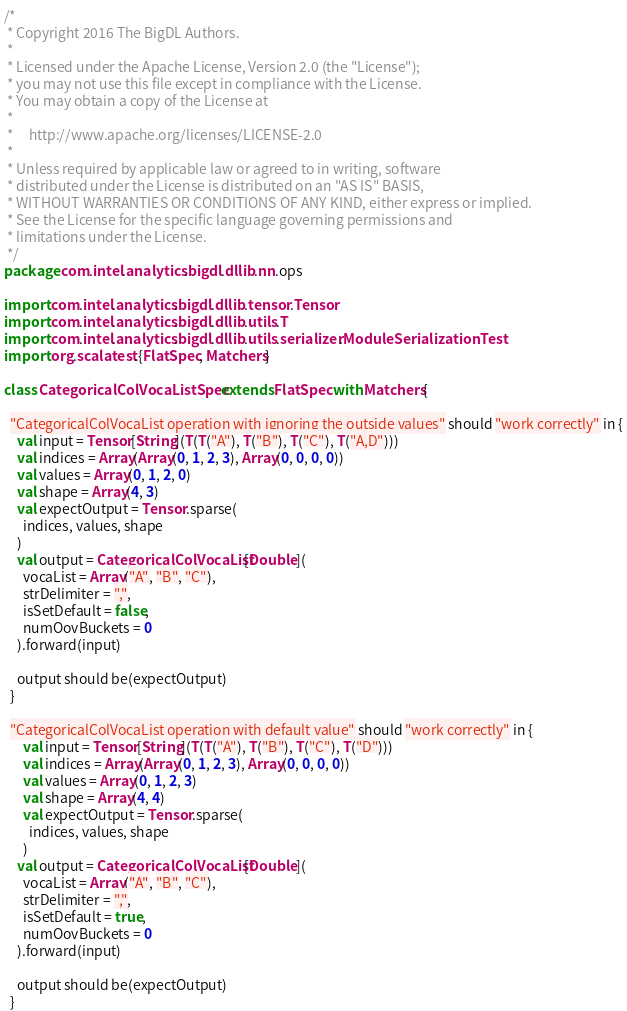<code> <loc_0><loc_0><loc_500><loc_500><_Scala_>/*
 * Copyright 2016 The BigDL Authors.
 *
 * Licensed under the Apache License, Version 2.0 (the "License");
 * you may not use this file except in compliance with the License.
 * You may obtain a copy of the License at
 *
 *     http://www.apache.org/licenses/LICENSE-2.0
 *
 * Unless required by applicable law or agreed to in writing, software
 * distributed under the License is distributed on an "AS IS" BASIS,
 * WITHOUT WARRANTIES OR CONDITIONS OF ANY KIND, either express or implied.
 * See the License for the specific language governing permissions and
 * limitations under the License.
 */
package com.intel.analytics.bigdl.dllib.nn.ops

import com.intel.analytics.bigdl.dllib.tensor.Tensor
import com.intel.analytics.bigdl.dllib.utils.T
import com.intel.analytics.bigdl.dllib.utils.serializer.ModuleSerializationTest
import org.scalatest.{FlatSpec, Matchers}

class CategoricalColVocaListSpec extends FlatSpec with Matchers{

  "CategoricalColVocaList operation with ignoring the outside values" should "work correctly" in {
    val input = Tensor[String](T(T("A"), T("B"), T("C"), T("A,D")))
    val indices = Array(Array(0, 1, 2, 3), Array(0, 0, 0, 0))
    val values = Array(0, 1, 2, 0)
    val shape = Array(4, 3)
    val expectOutput = Tensor.sparse(
      indices, values, shape
    )
    val output = CategoricalColVocaList[Double](
      vocaList = Array("A", "B", "C"),
      strDelimiter = ",",
      isSetDefault = false,
      numOovBuckets = 0
    ).forward(input)

    output should be(expectOutput)
  }

  "CategoricalColVocaList operation with default value" should "work correctly" in {
      val input = Tensor[String](T(T("A"), T("B"), T("C"), T("D")))
      val indices = Array(Array(0, 1, 2, 3), Array(0, 0, 0, 0))
      val values = Array(0, 1, 2, 3)
      val shape = Array(4, 4)
      val expectOutput = Tensor.sparse(
        indices, values, shape
      )
    val output = CategoricalColVocaList[Double](
      vocaList = Array("A", "B", "C"),
      strDelimiter = ",",
      isSetDefault = true,
      numOovBuckets = 0
    ).forward(input)

    output should be(expectOutput)
  }
</code> 